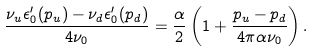<formula> <loc_0><loc_0><loc_500><loc_500>\frac { \nu _ { u } \epsilon ^ { \prime } _ { 0 } ( p _ { u } ) - \nu _ { d } \epsilon ^ { \prime } _ { 0 } ( p _ { d } ) } { 4 \nu _ { 0 } } = \frac { \alpha } { 2 } \left ( 1 + \frac { p _ { u } - p _ { d } } { 4 \pi \alpha \nu _ { 0 } } \right ) .</formula> 